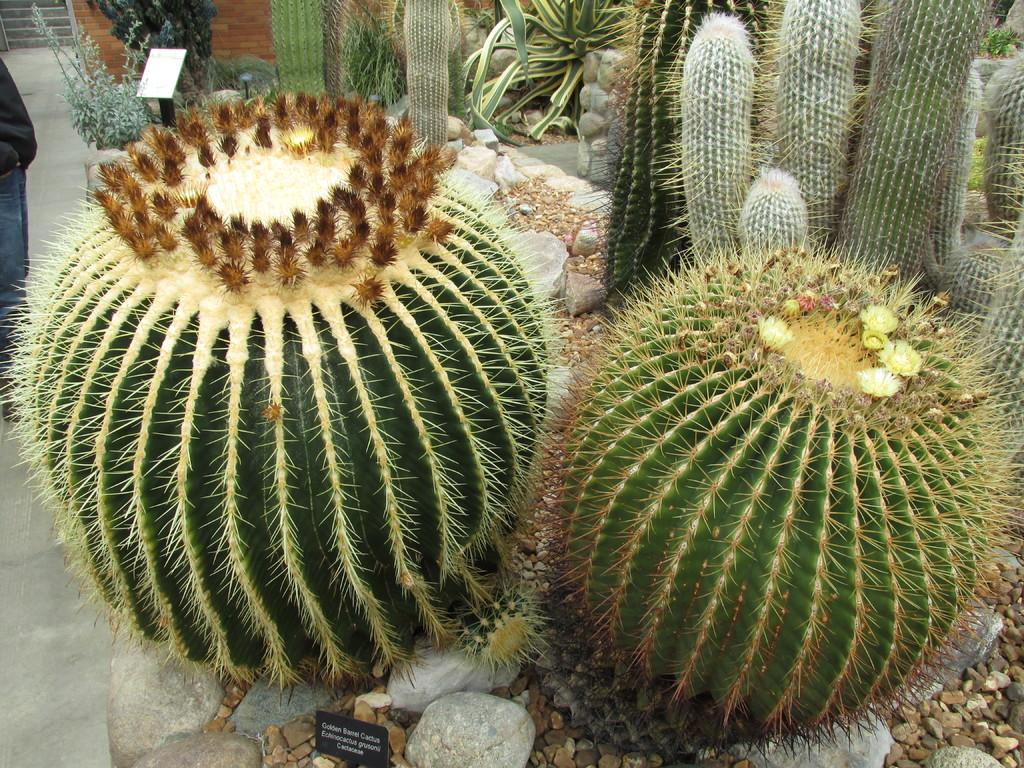What type of plants are in the image? There are cactus plants in the image. What other objects can be seen in the image? There are stones visible in the image. What is the person in the image doing? The person is standing on the road in the image. What architectural feature can be seen in the background of the image? There are stairs visible in the background of the image. Where is the library located in the image? There is no library present in the image. What type of writing instrument is the person holding in the image? The person is not holding any writing instrument in the image. 